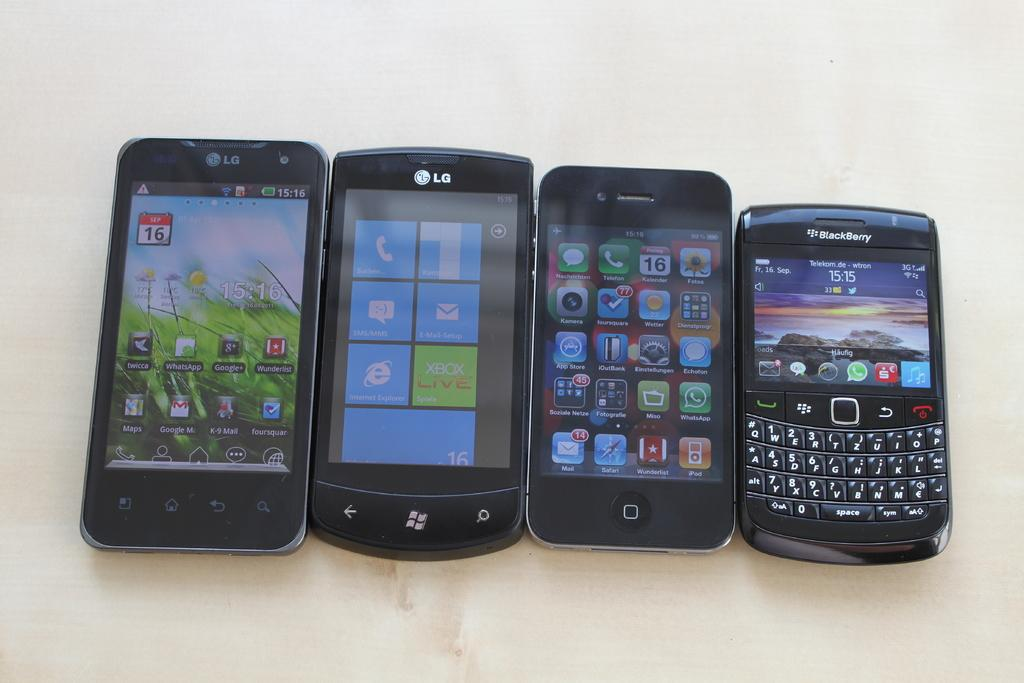<image>
Create a compact narrative representing the image presented. Phones from companies such as LG and Blackberry 